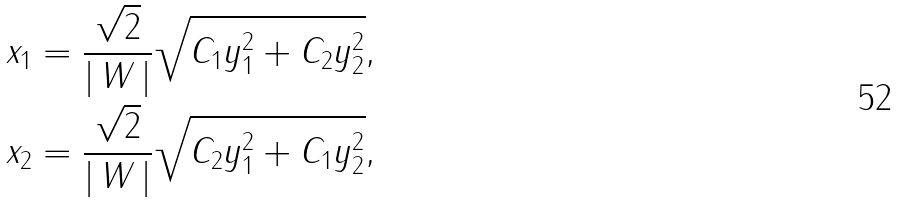Convert formula to latex. <formula><loc_0><loc_0><loc_500><loc_500>x _ { 1 } & = \frac { \sqrt { 2 } } { | \, W \, | } \sqrt { C _ { 1 } y _ { 1 } ^ { 2 } + C _ { 2 } y _ { 2 } ^ { 2 } } , \\ x _ { 2 } & = \frac { \sqrt { 2 } } { | \, W \, | } \sqrt { C _ { 2 } y _ { 1 } ^ { 2 } + C _ { 1 } y _ { 2 } ^ { 2 } } ,</formula> 